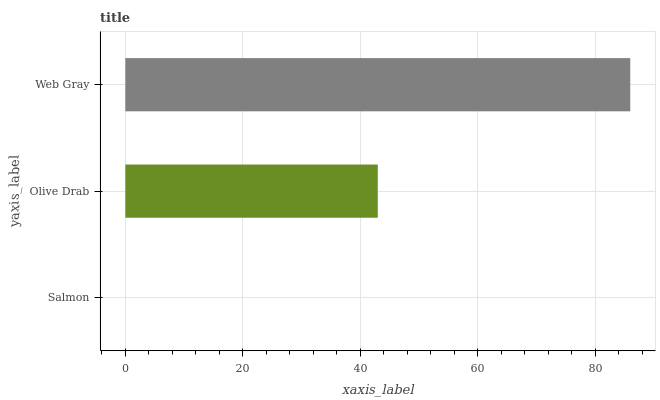Is Salmon the minimum?
Answer yes or no. Yes. Is Web Gray the maximum?
Answer yes or no. Yes. Is Olive Drab the minimum?
Answer yes or no. No. Is Olive Drab the maximum?
Answer yes or no. No. Is Olive Drab greater than Salmon?
Answer yes or no. Yes. Is Salmon less than Olive Drab?
Answer yes or no. Yes. Is Salmon greater than Olive Drab?
Answer yes or no. No. Is Olive Drab less than Salmon?
Answer yes or no. No. Is Olive Drab the high median?
Answer yes or no. Yes. Is Olive Drab the low median?
Answer yes or no. Yes. Is Salmon the high median?
Answer yes or no. No. Is Salmon the low median?
Answer yes or no. No. 